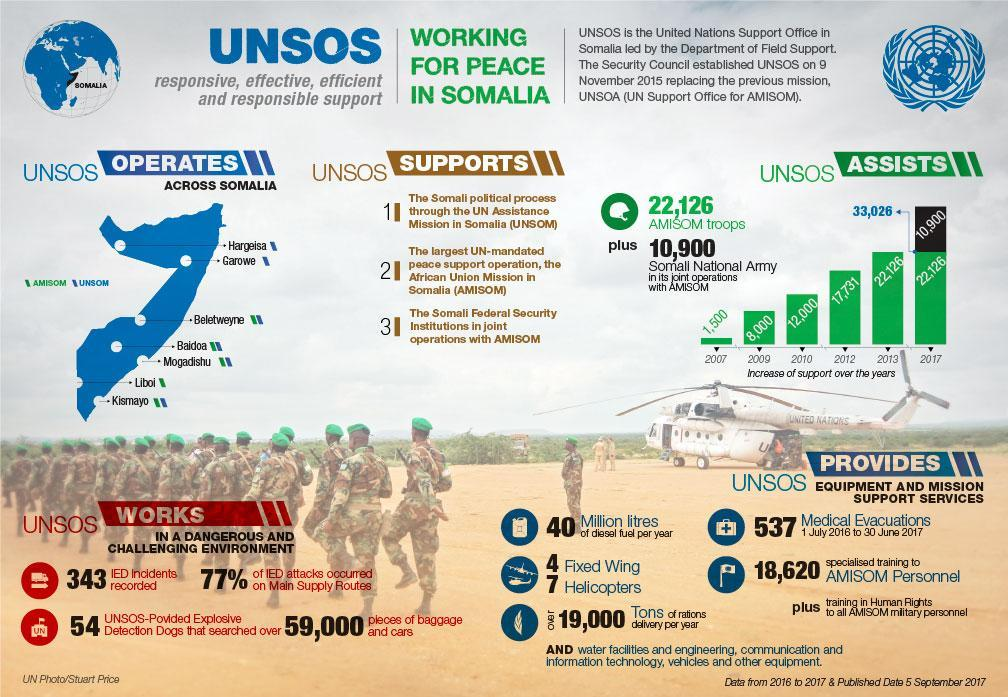How many medical evacuations were done with the support of UNSOS from 1 July 2016 to 30 June 2017?
Answer the question with a short phrase. 537 How many troops were deployed by the UNSOS for AMISOM mission in 2012? 17,731 How many troops were deployed by the UNSOS for AMISOM mission in 2010? 12,000 In which year, the Somali National Army came in its joint operations with AMISOM? 2017 How many litres of diesel fuel per year is provided by the UNSOS? 40 Million What is the total number of task forces deployed for the AMISOM mission by UNSOS? 33,026 